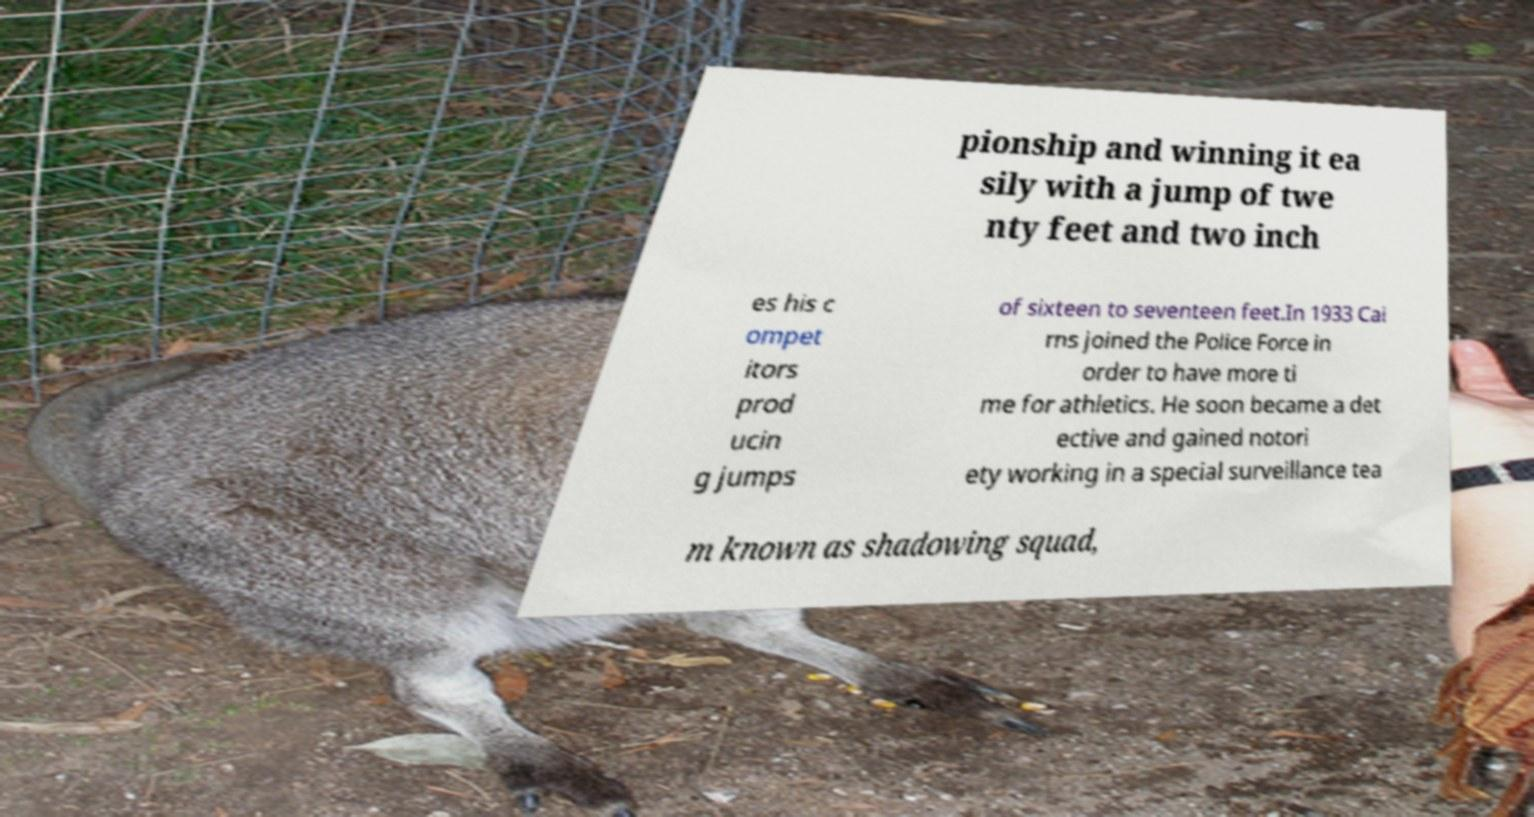Could you extract and type out the text from this image? pionship and winning it ea sily with a jump of twe nty feet and two inch es his c ompet itors prod ucin g jumps of sixteen to seventeen feet.In 1933 Cai rns joined the Police Force in order to have more ti me for athletics. He soon became a det ective and gained notori ety working in a special surveillance tea m known as shadowing squad, 